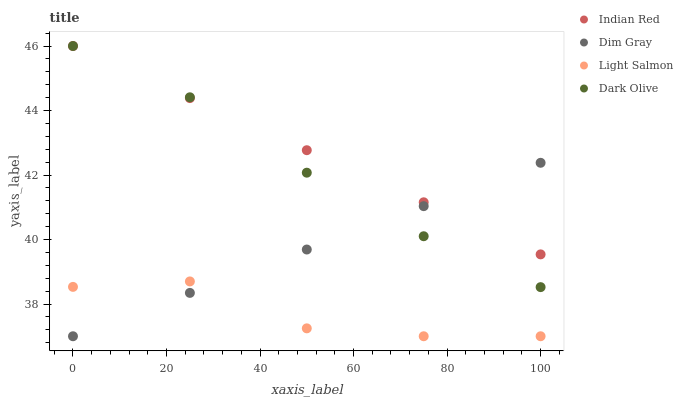Does Light Salmon have the minimum area under the curve?
Answer yes or no. Yes. Does Indian Red have the maximum area under the curve?
Answer yes or no. Yes. Does Dim Gray have the minimum area under the curve?
Answer yes or no. No. Does Dim Gray have the maximum area under the curve?
Answer yes or no. No. Is Dim Gray the smoothest?
Answer yes or no. Yes. Is Light Salmon the roughest?
Answer yes or no. Yes. Is Light Salmon the smoothest?
Answer yes or no. No. Is Dim Gray the roughest?
Answer yes or no. No. Does Light Salmon have the lowest value?
Answer yes or no. Yes. Does Indian Red have the lowest value?
Answer yes or no. No. Does Indian Red have the highest value?
Answer yes or no. Yes. Does Dim Gray have the highest value?
Answer yes or no. No. Is Light Salmon less than Dark Olive?
Answer yes or no. Yes. Is Dark Olive greater than Light Salmon?
Answer yes or no. Yes. Does Dark Olive intersect Dim Gray?
Answer yes or no. Yes. Is Dark Olive less than Dim Gray?
Answer yes or no. No. Is Dark Olive greater than Dim Gray?
Answer yes or no. No. Does Light Salmon intersect Dark Olive?
Answer yes or no. No. 